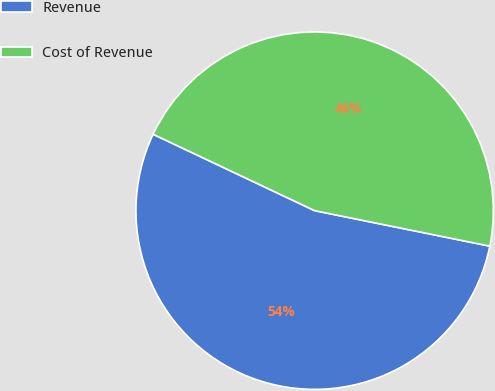Convert chart. <chart><loc_0><loc_0><loc_500><loc_500><pie_chart><fcel>Revenue<fcel>Cost of Revenue<nl><fcel>53.85%<fcel>46.15%<nl></chart> 